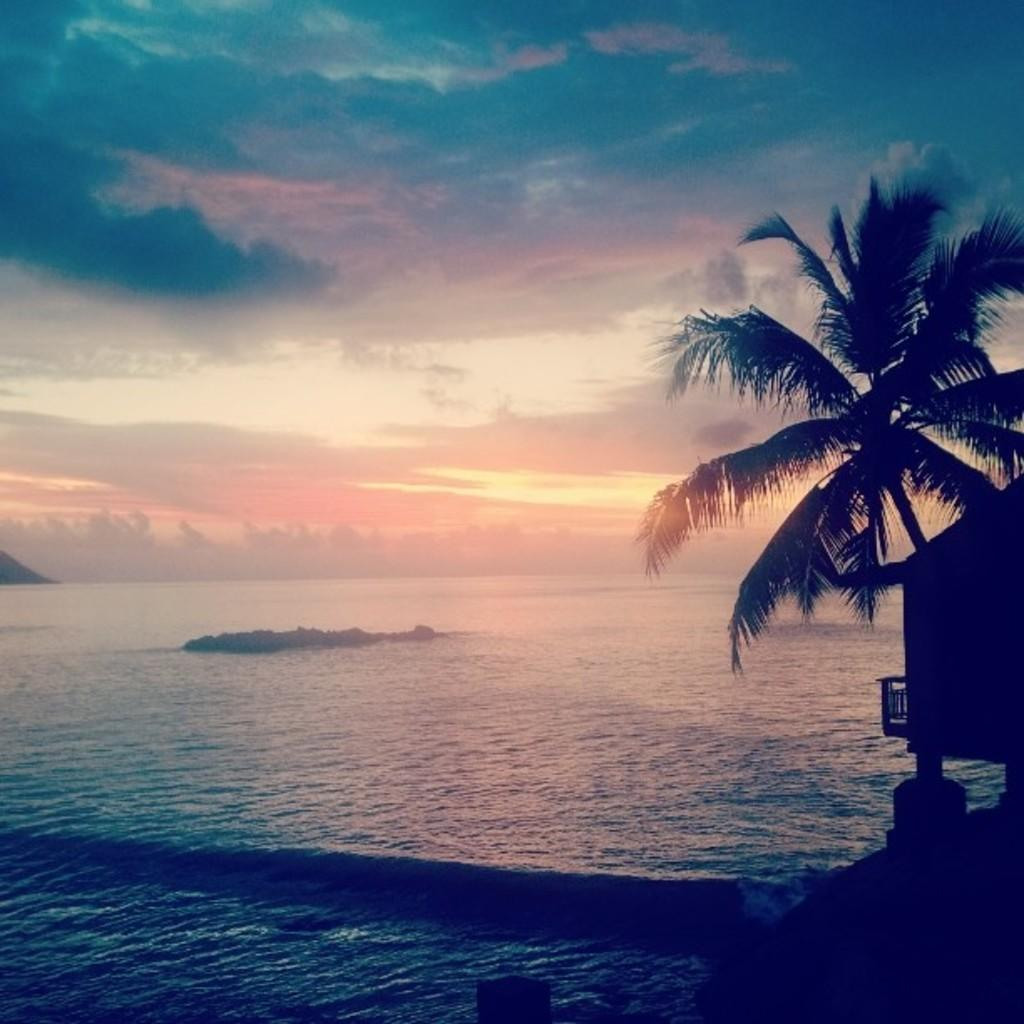What type of natural feature can be seen in the image? There is an ocean in the image. What other natural feature is visible in the image? There are mountains in the image. What part of the sky is visible in the image? The sky is visible in the image. What can be seen in the sky? Clouds are present in the sky. What man-made object is in the image? There is a boat in the image. What type of plant is in the image? There is a tree in the image. What type of breakfast is being served on the edge of the ocean in the image? There is no breakfast or edge of the ocean present in the image; it features an ocean, mountains, sky, clouds, a boat, and a tree. 